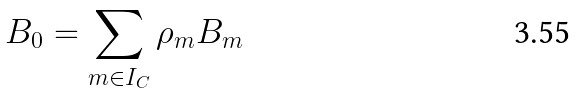<formula> <loc_0><loc_0><loc_500><loc_500>B _ { 0 } = \sum _ { m \in I _ { C } } \rho _ { m } B _ { m }</formula> 